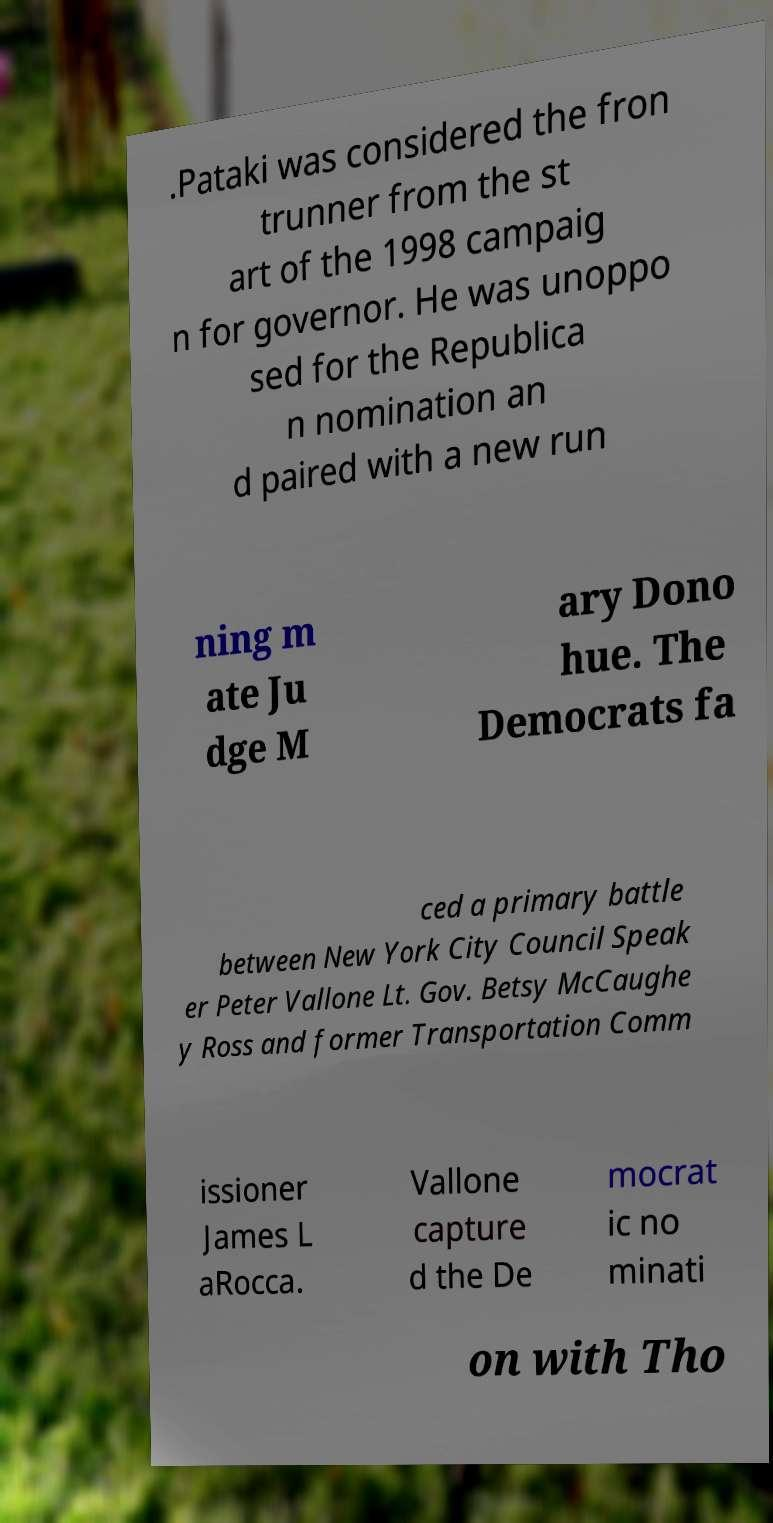There's text embedded in this image that I need extracted. Can you transcribe it verbatim? .Pataki was considered the fron trunner from the st art of the 1998 campaig n for governor. He was unoppo sed for the Republica n nomination an d paired with a new run ning m ate Ju dge M ary Dono hue. The Democrats fa ced a primary battle between New York City Council Speak er Peter Vallone Lt. Gov. Betsy McCaughe y Ross and former Transportation Comm issioner James L aRocca. Vallone capture d the De mocrat ic no minati on with Tho 